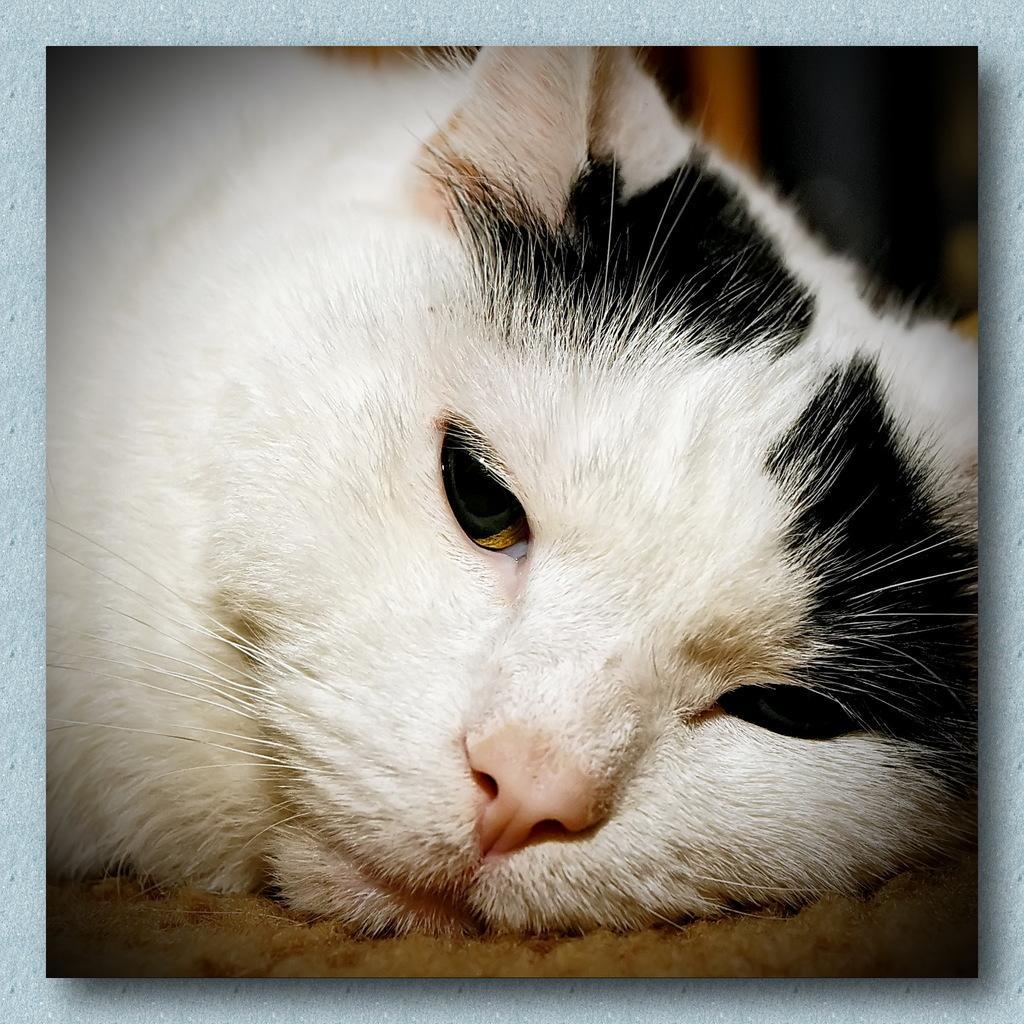Describe this image in one or two sentences. In this image we can see the cat. 